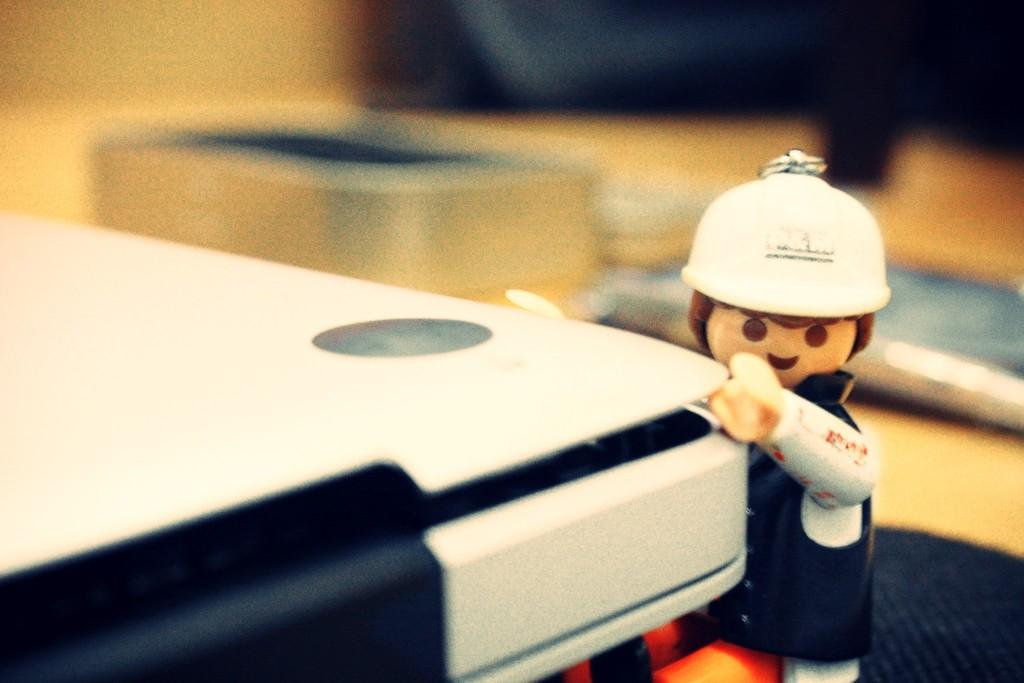What is the main object in the image? There is a toy in the image. Can you describe any other objects present in the image? There are other objects in the image, but their specific details are not mentioned in the provided facts. How many rabbits are playing basketball in the image? There are no rabbits or basketball in the image. 